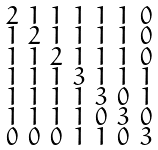<formula> <loc_0><loc_0><loc_500><loc_500>\begin{smallmatrix} 2 & 1 & 1 & 1 & 1 & 1 & 0 \\ 1 & 2 & 1 & 1 & 1 & 1 & 0 \\ 1 & 1 & 2 & 1 & 1 & 1 & 0 \\ 1 & 1 & 1 & 3 & 1 & 1 & 1 \\ 1 & 1 & 1 & 1 & 3 & 0 & 1 \\ 1 & 1 & 1 & 1 & 0 & 3 & 0 \\ 0 & 0 & 0 & 1 & 1 & 0 & 3 \end{smallmatrix}</formula> 